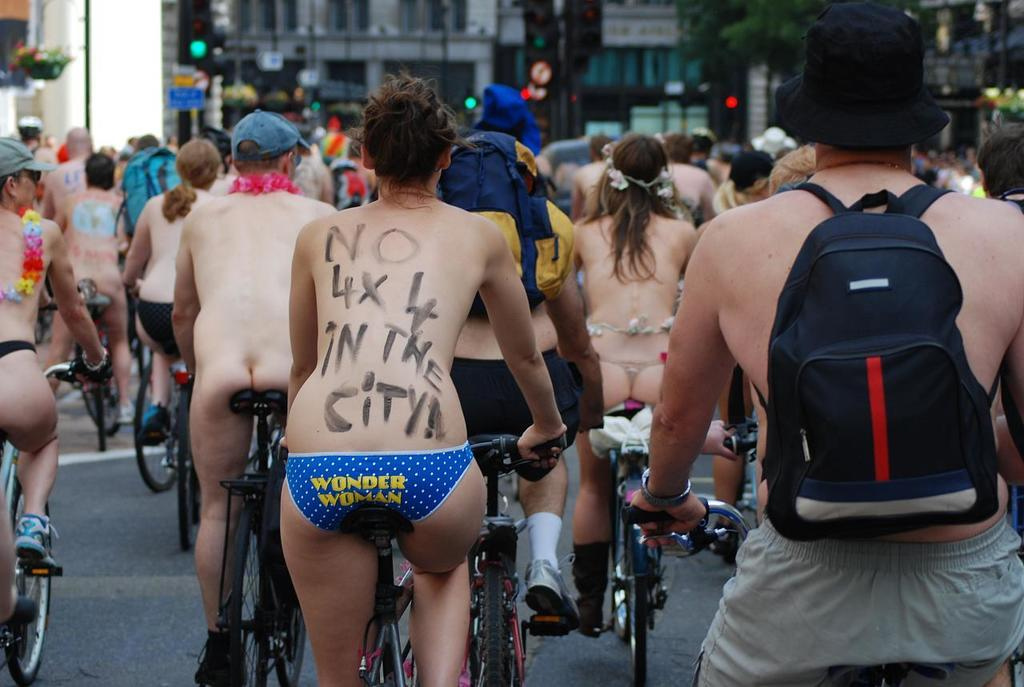What are the people in the image doing? The people in the image are riding bicycles. Where are the people riding their bicycles? The bicycles are on a road. What can be seen in the background of the image? There are buildings in the background of the image. What features do the buildings have? The buildings have walls and windows. What type of holiday is being celebrated in the image? There is no indication of a holiday being celebrated in the image; it simply shows a group of people riding bicycles on a road. What amusement park can be seen in the background of the image? There is no amusement park visible in the image; only buildings with walls and windows are present in the background. 